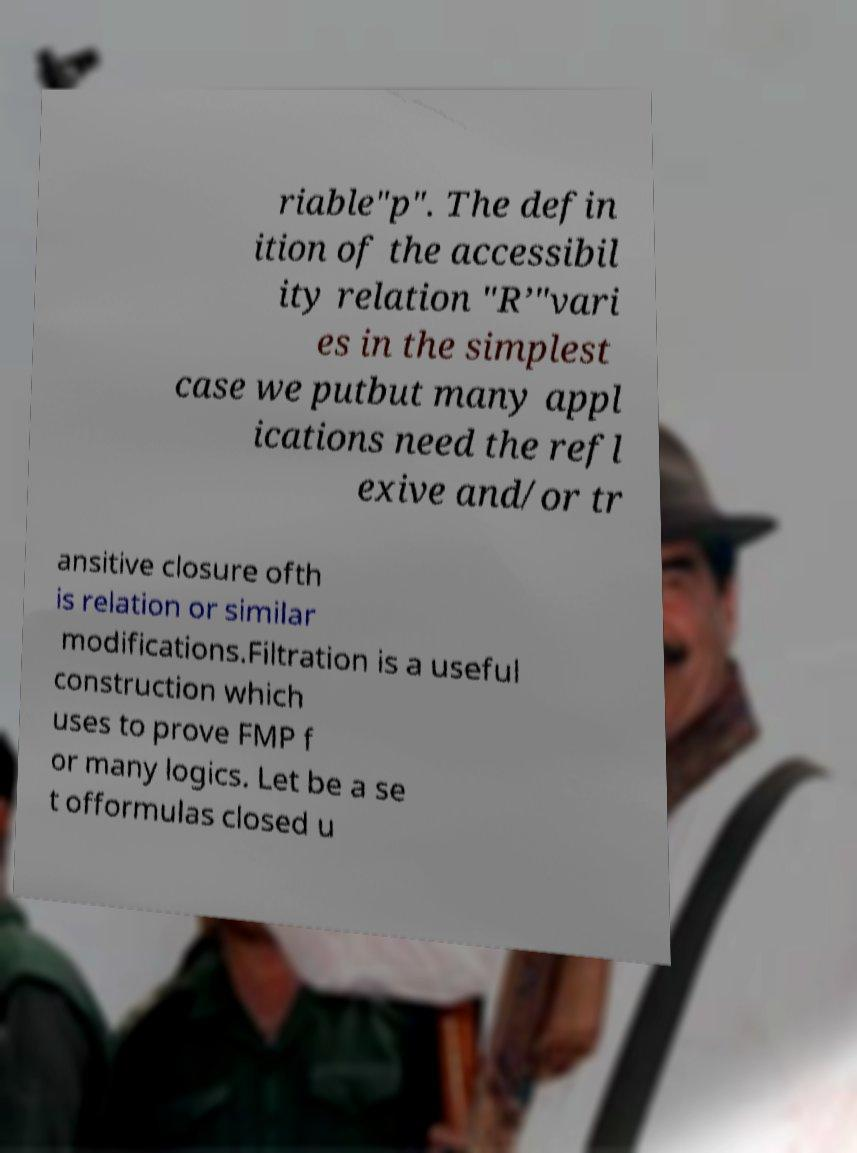Please identify and transcribe the text found in this image. riable"p". The defin ition of the accessibil ity relation "R’"vari es in the simplest case we putbut many appl ications need the refl exive and/or tr ansitive closure ofth is relation or similar modifications.Filtration is a useful construction which uses to prove FMP f or many logics. Let be a se t offormulas closed u 